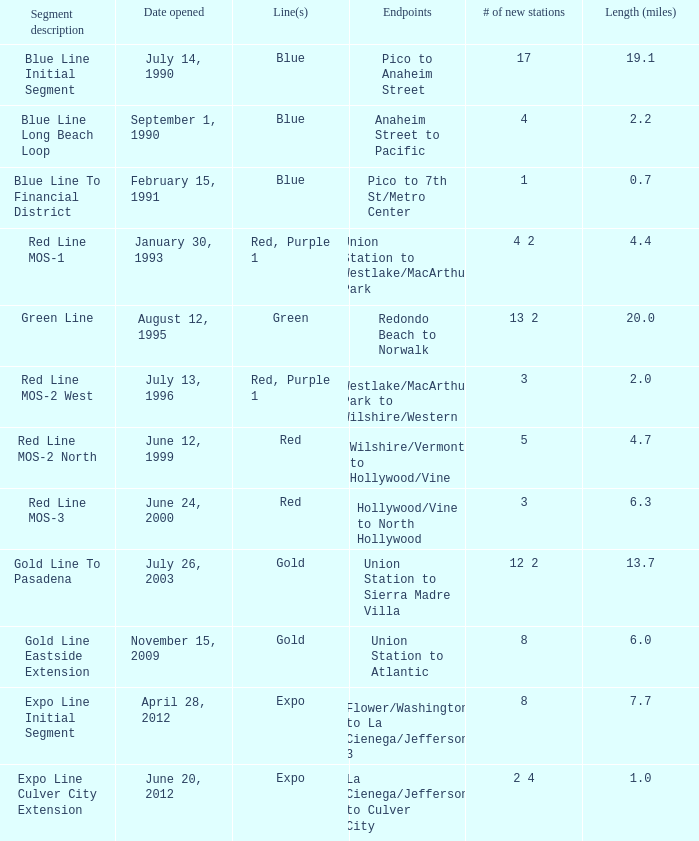What is the span (miles) when pico and 7th st/metro center are the terminals? 0.7. 